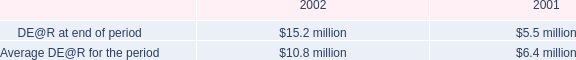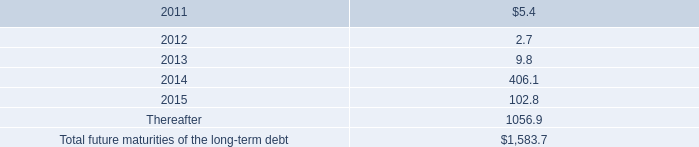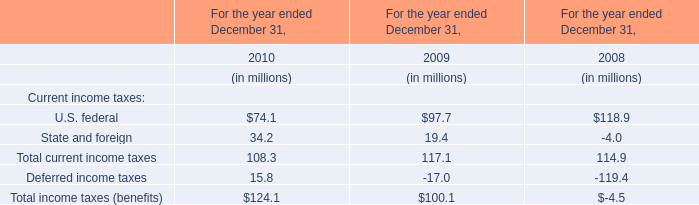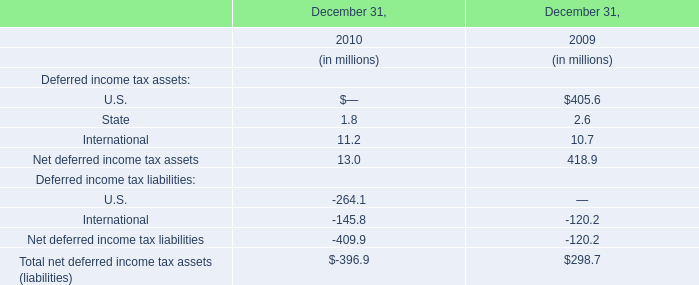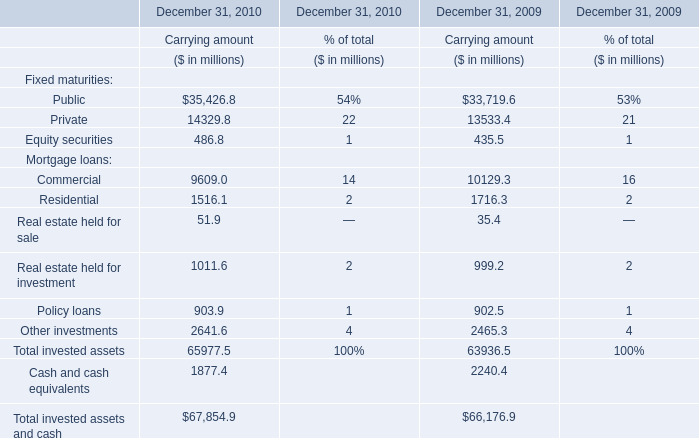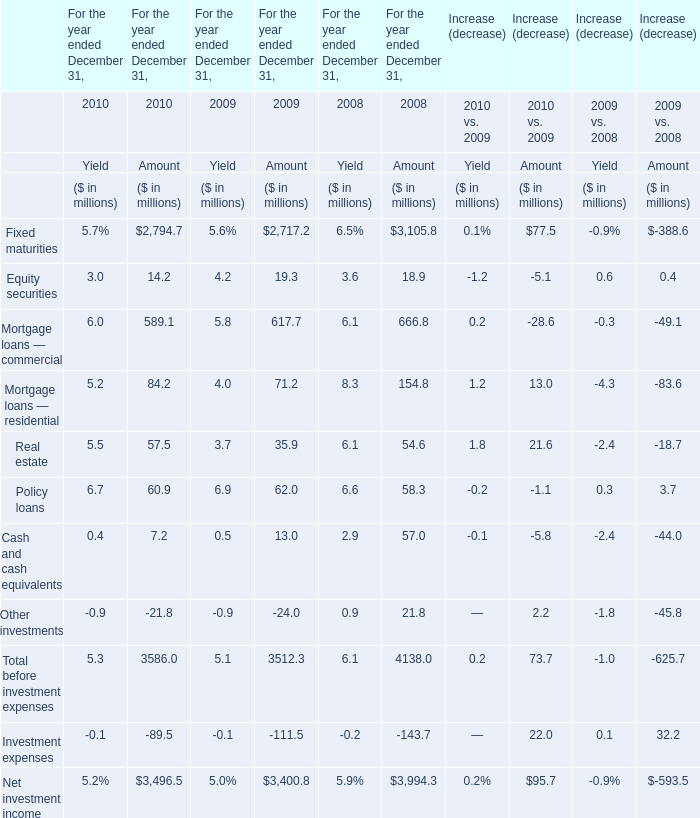For the year ended December 31,which year is the amount of Equity securities less than 15 million? 
Answer: 2010. 